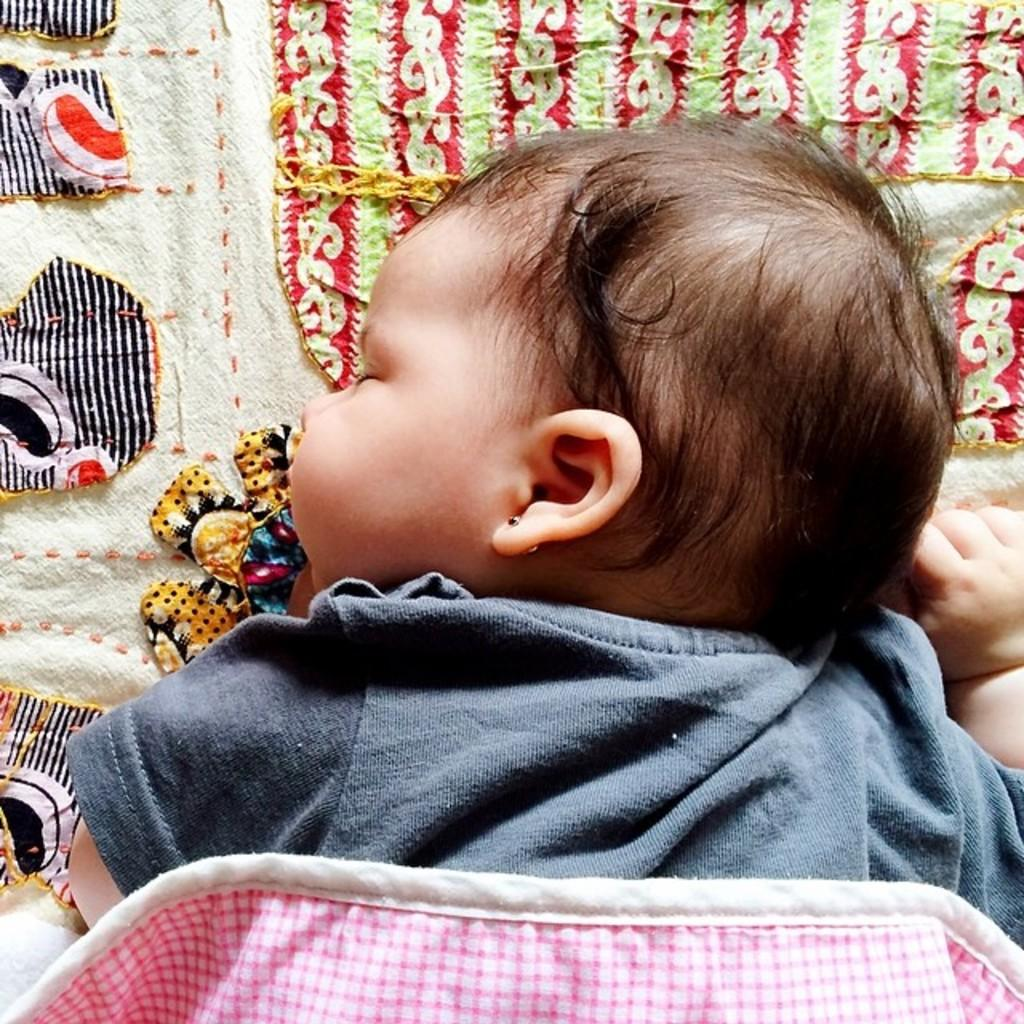Who is the main subject in the image? There is a child in the image. What is the child doing in the image? The child is sleeping on a bed. What type of songs can be heard playing in the background of the image? There is no information about songs or background music in the image, as it only shows a child sleeping on a bed. 